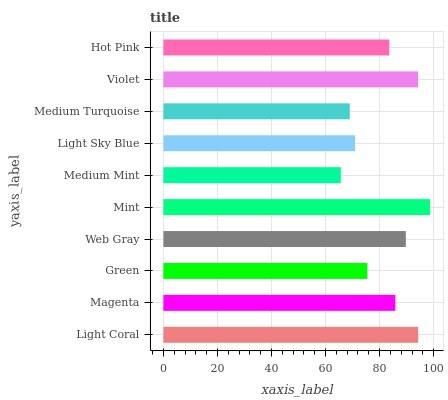Is Medium Mint the minimum?
Answer yes or no. Yes. Is Mint the maximum?
Answer yes or no. Yes. Is Magenta the minimum?
Answer yes or no. No. Is Magenta the maximum?
Answer yes or no. No. Is Light Coral greater than Magenta?
Answer yes or no. Yes. Is Magenta less than Light Coral?
Answer yes or no. Yes. Is Magenta greater than Light Coral?
Answer yes or no. No. Is Light Coral less than Magenta?
Answer yes or no. No. Is Magenta the high median?
Answer yes or no. Yes. Is Hot Pink the low median?
Answer yes or no. Yes. Is Green the high median?
Answer yes or no. No. Is Green the low median?
Answer yes or no. No. 